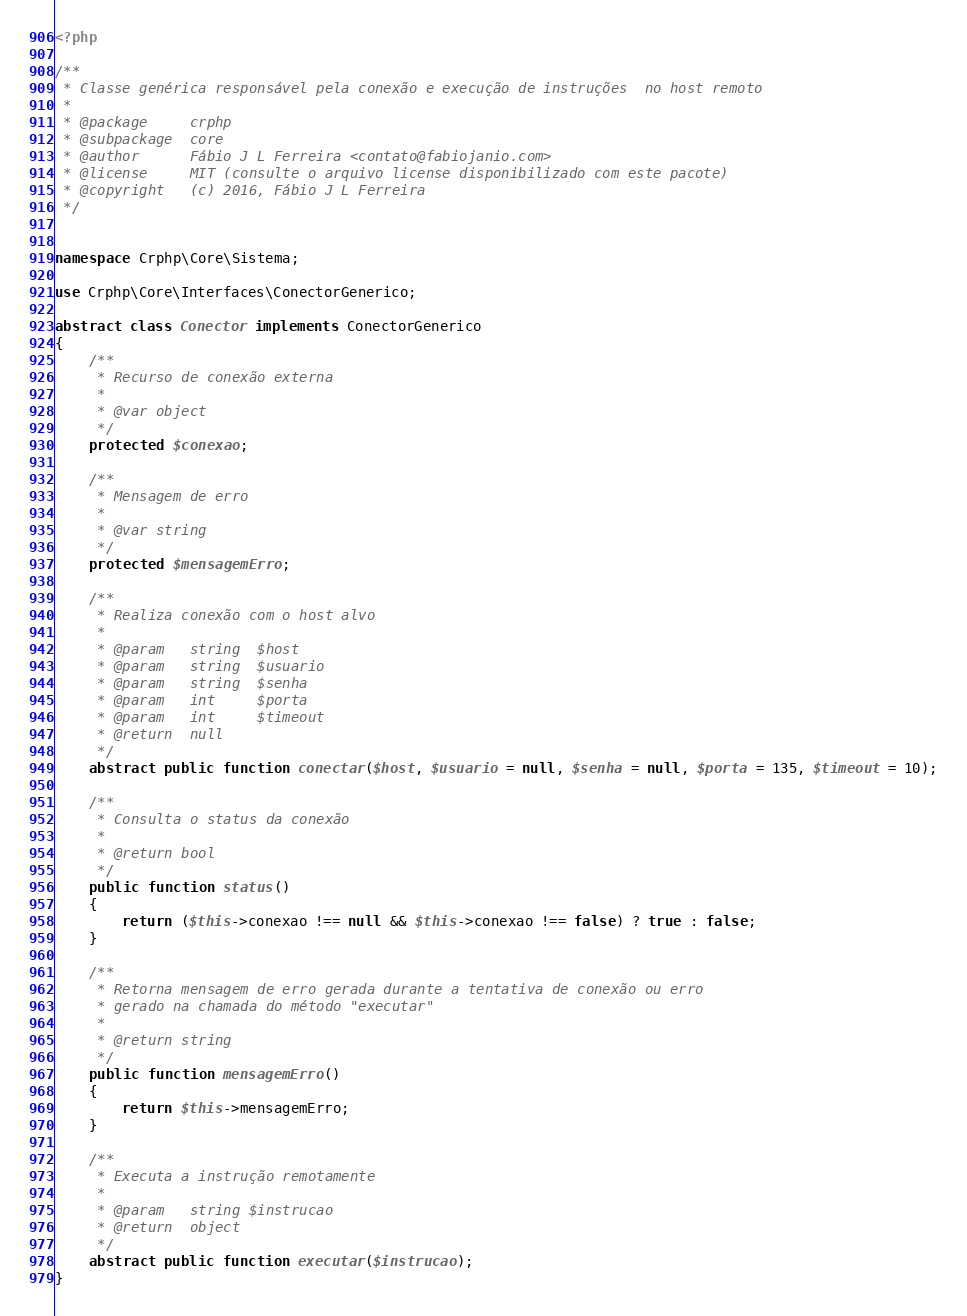<code> <loc_0><loc_0><loc_500><loc_500><_PHP_><?php

/**
 * Classe genérica responsável pela conexão e execução de instruções  no host remoto
 * 
 * @package     crphp
 * @subpackage  core
 * @author      Fábio J L Ferreira <contato@fabiojanio.com>
 * @license     MIT (consulte o arquivo license disponibilizado com este pacote)
 * @copyright   (c) 2016, Fábio J L Ferreira
 */


namespace Crphp\Core\Sistema;

use Crphp\Core\Interfaces\ConectorGenerico;

abstract class Conector implements ConectorGenerico
{
    /**
     * Recurso de conexão externa
     * 
     * @var object
     */
    protected $conexao;

    /**
     * Mensagem de erro
     * 
     * @var string
     */
    protected $mensagemErro;

    /**
     * Realiza conexão com o host alvo
     * 
     * @param   string  $host
     * @param   string  $usuario
     * @param   string  $senha
     * @param   int     $porta
     * @param   int     $timeout
     * @return  null
     */
    abstract public function conectar($host, $usuario = null, $senha = null, $porta = 135, $timeout = 10);
    
    /**
     * Consulta o status da conexão
     * 
     * @return bool
     */
    public function status()
    {
        return ($this->conexao !== null && $this->conexao !== false) ? true : false;
    }

    /**
     * Retorna mensagem de erro gerada durante a tentativa de conexão ou erro 
     * gerado na chamada do método "executar"
     * 
     * @return string
     */
    public function mensagemErro()
    {
        return $this->mensagemErro;
    }

    /**
     * Executa a instrução remotamente
     * 
     * @param   string $instrucao
     * @return  object
     */
    abstract public function executar($instrucao);
}</code> 